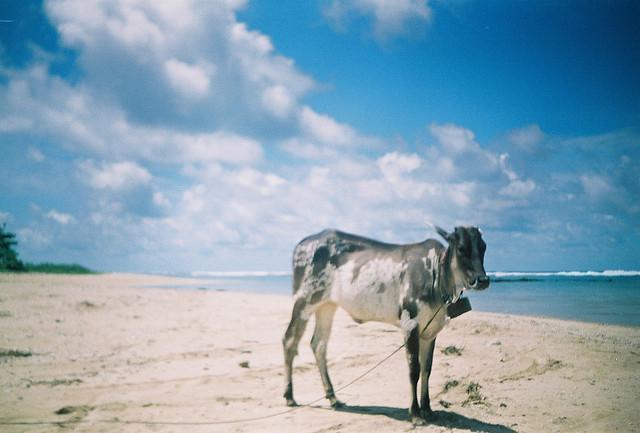How many animals are there?
Give a very brief answer. 1. 